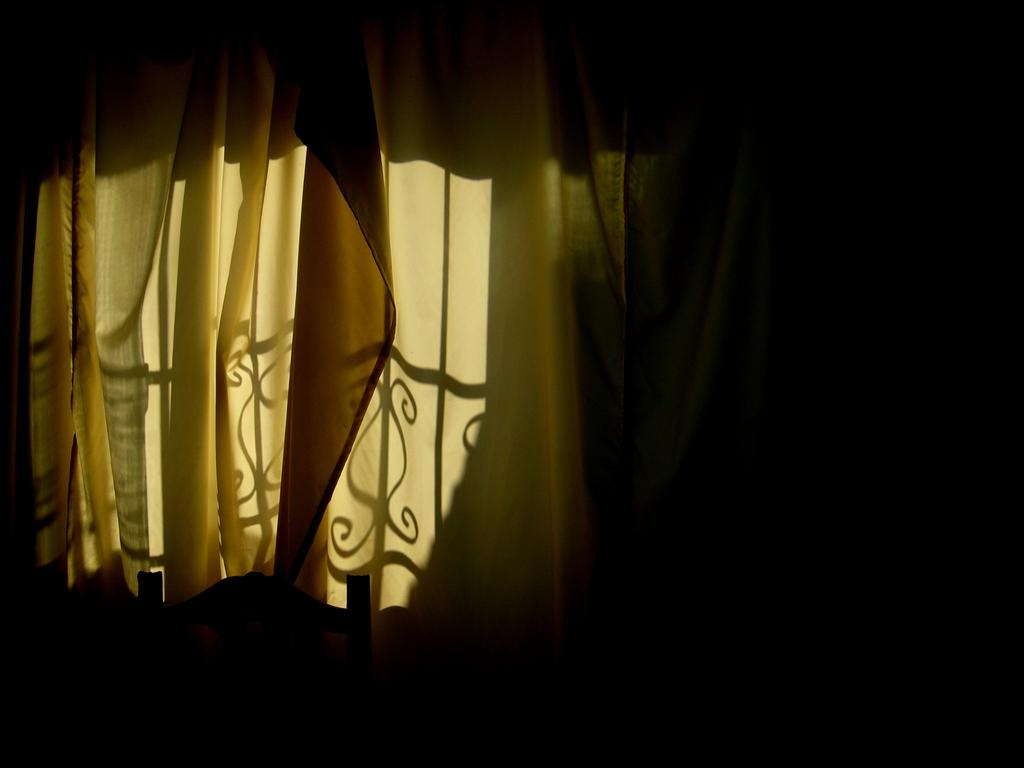What type of window treatment is visible in the image? There are curtains in the image. Can you describe the lighting in the image? The image is dark. What type of dinner is being served in the image? There is no dinner present in the image. How many bubbles can be seen in the image? There are no bubbles present in the image. 